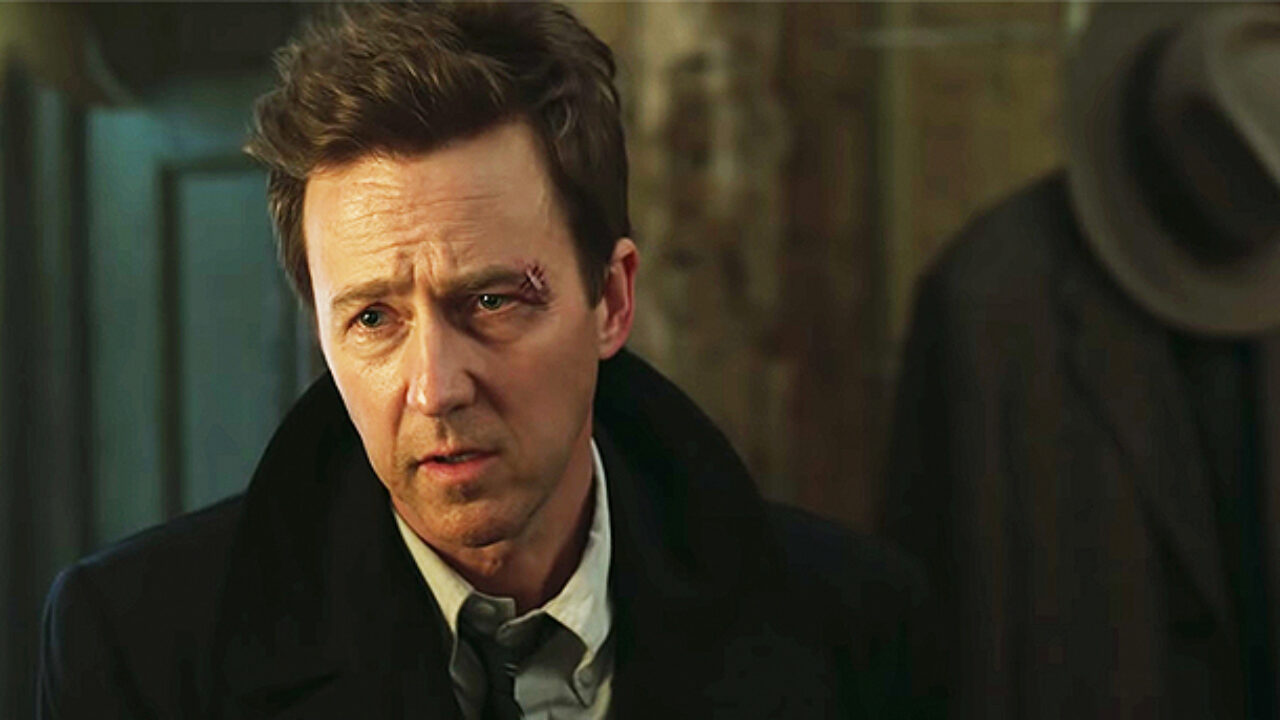What does the individual's expression tell us about his emotional state? The individual's expression, marked by furrowed brows and slightly parted lips, conveys a sense of worry or anxiety. The overall demeanor suggests that he might be under stress or facing a difficult situation. His disheveled hair and the solemnity of his formal attire add layers to his emotional state, hinting at a scene of high stakes or serious implications. Can you guess what might have happened before this moment in the scene? Considering his concerned expression and the formal attire, it's possible that the individual might have just experienced a critical event, perhaps a confrontation or unsettling news. The disheveled hair suggests he was active or stressed, possibly having moved hurriedly or been in a physical altercation. The setting's dim lighting and presence of the hat rack hint that this might be an indoor scene, potentially in an office or a study, where he has retreated to process the event. Why is the setting dimly lit, and how does that influence the scene? The dim lighting in the room amplifies the tension and sense of foreboding in the scene. It creates an atmosphere of mystery and focus, drawing attention to the individual's expressive face and enhancing the gravity of the moment. The shadows and muted colors add to the dramatic effect, making the scene feel more intimate and charged with emotional intensity. 